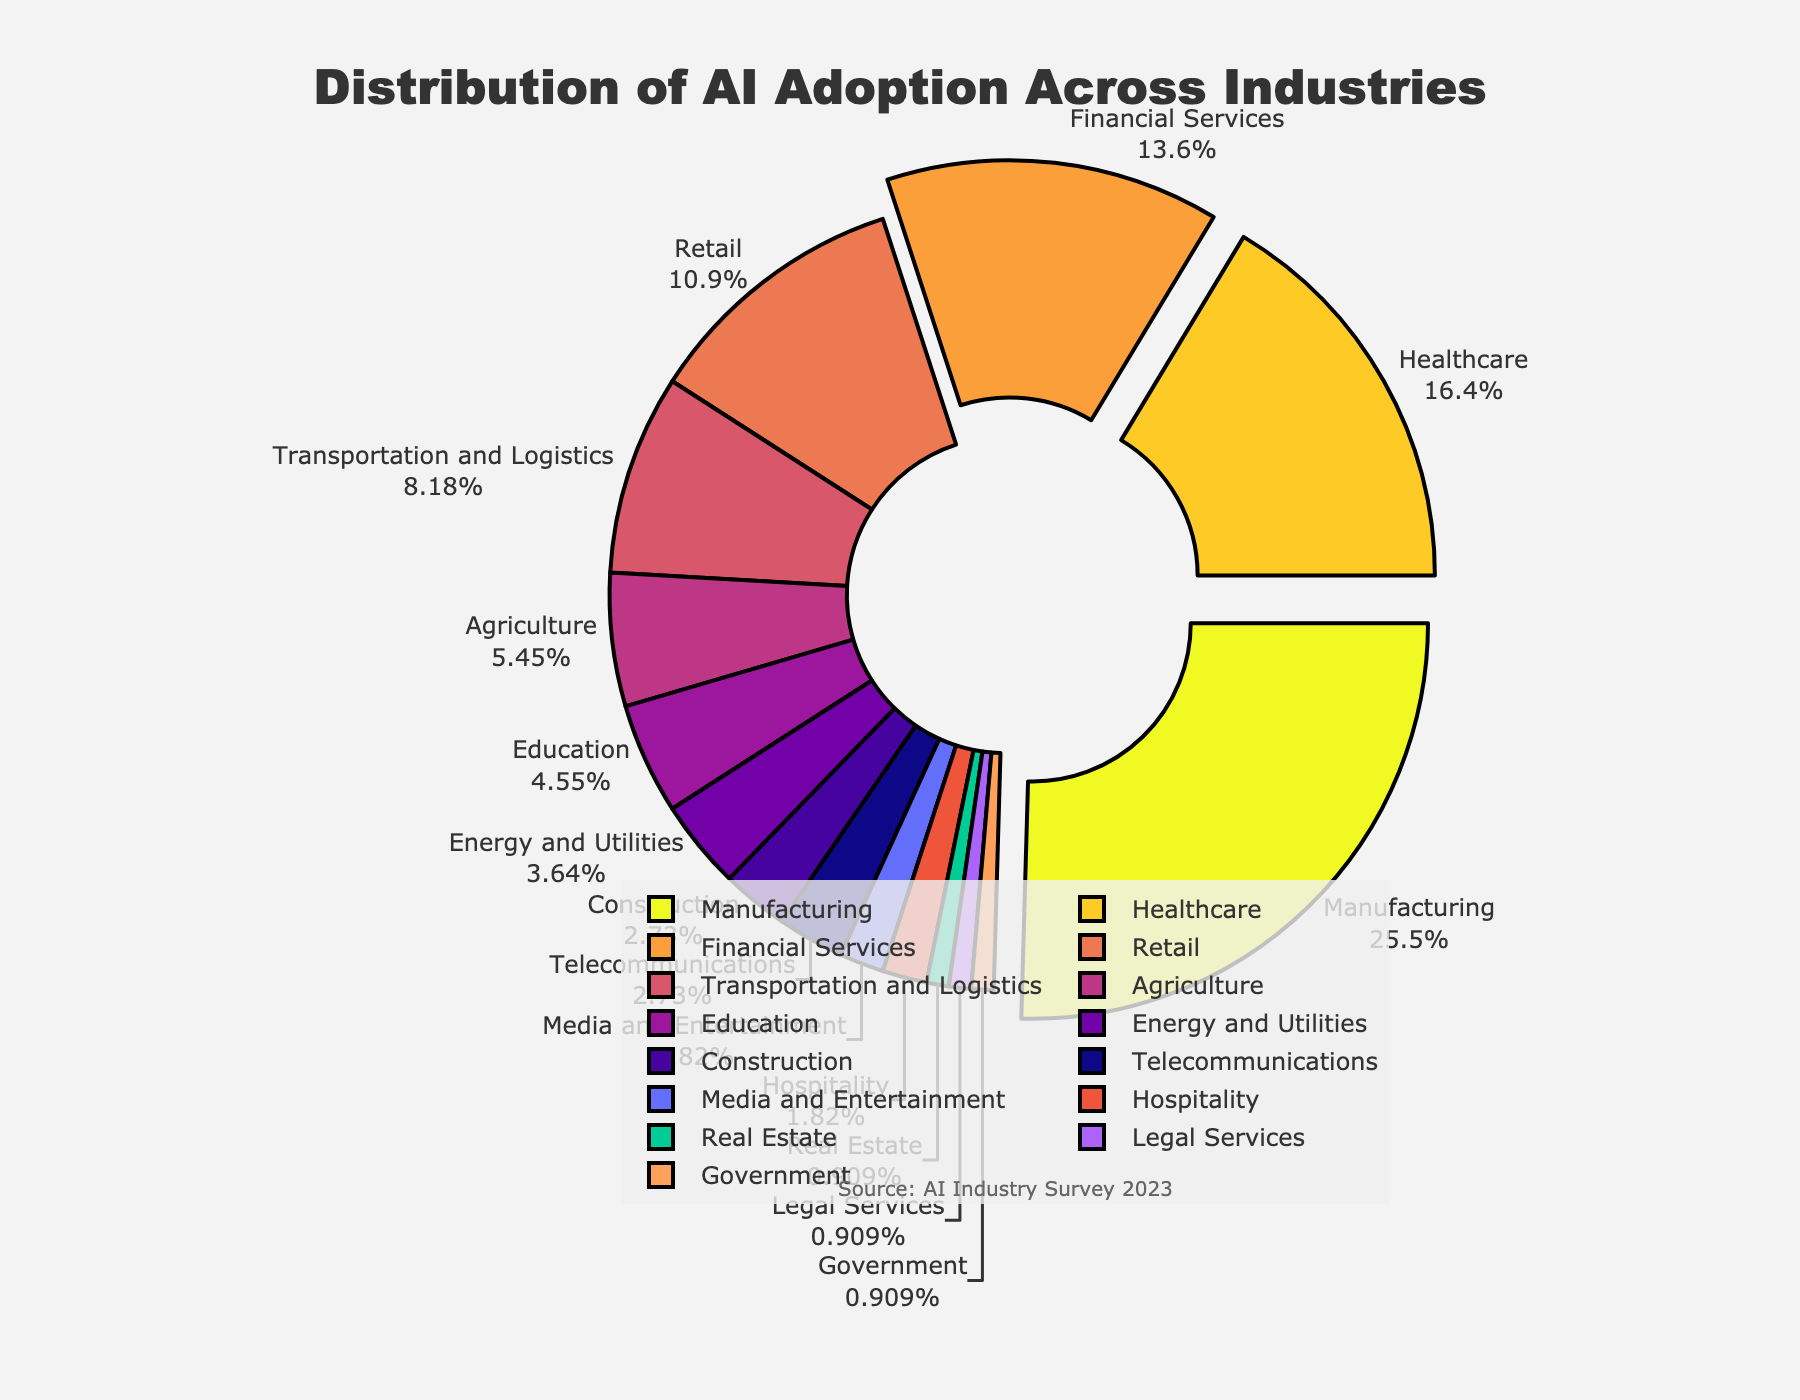Which industry has the highest percentage of AI adoption? The slice representing Manufacturing is the largest in the pie chart, which means it has the highest percentage of AI adoption.
Answer: Manufacturing What is the combined percentage of AI adoption in the top three industries? The top three industries by AI adoption percentages are Manufacturing (28%), Healthcare (18%), and Financial Services (15%). Adding these together gives 28 + 18 + 15 = 61%.
Answer: 61% How does AI adoption in the Education sector compare to the Healthcare sector? The pie chart shows that Education has a percentage of 5% while Healthcare has 18%. Therefore, AI adoption in the Healthcare sector is significantly higher compared to Education.
Answer: Healthcare has higher AI adoption Which industry has the lowest percentage of AI adoption and what is it? The smallest slices in the pie chart are for Real Estate, Legal Services, and Government, each with 1%.
Answer: Real Estate, Legal Services, and Government (each 1%) Is AI adoption in Telecommunications greater than in Construction? Both Telecommunications and Construction have the same percentage of AI adoption, which is 3%.
Answer: No, they are equal What is the difference in AI adoption percentage between Retail and Transportation and Logistics? Retail has 12% AI adoption while Transportation and Logistics have 9%. The difference is 12 - 9 = 3%.
Answer: 3% Which industries have AI adoption percentages below 5%? The pie chart shows that Agriculture, Education, Energy and Utilities, Construction, Telecommunications, Media and Entertainment, Hospitality, Real Estate, Legal Services, and Government all have percentages below 5%.
Answer: Agriculture, Education, Energy and Utilities, Construction, Telecommunications, Media and Entertainment, Hospitality, Real Estate, Legal Services, Government How do the AI adoption percentages of the Media and Entertainment and Hospitality sectors compare visually? Both the Media and Entertainment and Hospitality sectors have very small slices in the pie chart, with each representing 2% of AI adoption.
Answer: They are equal What is the total percentage of AI adoption represented by sectors with 6% or less adoption? The sectors with 6% or less adoption are Agriculture (6%), Education (5%), Energy and Utilities (4%), Construction (3%), Telecommunications (3%), Media and Entertainment (2%), Hospitality (2%), Real Estate (1%), Legal Services (1%), and Government (1%). Summing these gives 6 + 5 + 4 + 3 + 3 + 2 + 2 + 1 + 1 + 1 = 28%.
Answer: 28% Which sector has a similar AI adoption percentage to the Telecommunications sector? The Construction sector has the same AI adoption percentage as the Telecommunications sector, which is 3%.
Answer: Construction 